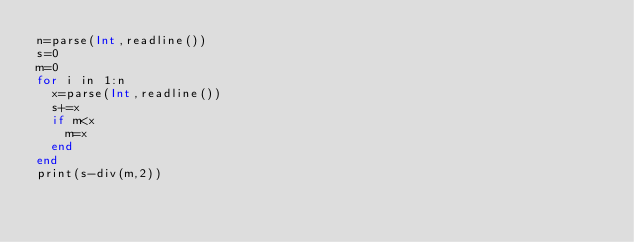<code> <loc_0><loc_0><loc_500><loc_500><_Julia_>n=parse(Int,readline())
s=0
m=0
for i in 1:n
  x=parse(Int,readline())
  s+=x
  if m<x
    m=x
  end
end
print(s-div(m,2))</code> 